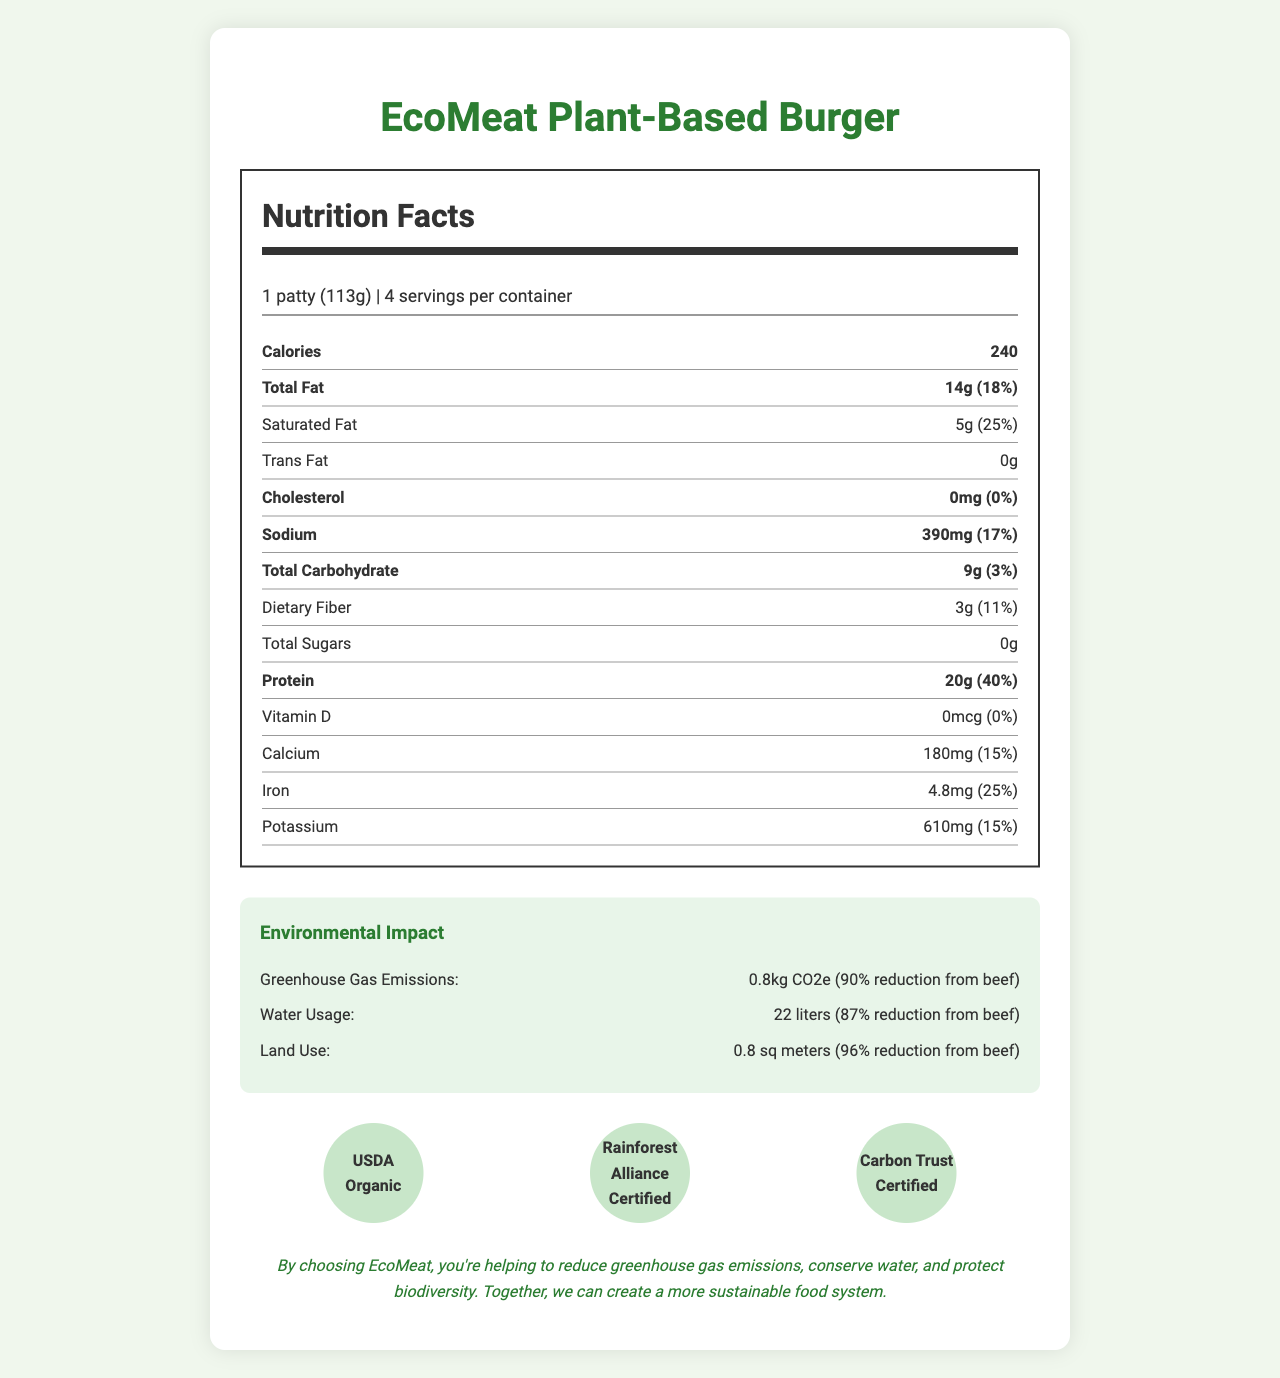what is the serving size for the EcoMeat Plant-Based Burger? The serving size is listed as "1 patty (113g)" under the nutrition facts section.
Answer: 1 patty (113g) how many grams of protein are in one serving? The nutrition facts section indicates that one serving contains 20 grams of protein.
Answer: 20g what daily value percentage of iron does one serving provide? The nutrition label shows that one serving provides 25% of the daily value of iron.
Answer: 25% how much sodium is in one serving of the product? The amount of sodium in one serving is listed as 390mg in the nutrition facts.
Answer: 390mg what is the total fat content in one serving? The nutrition facts section specifies that one serving contains 14g of total fat.
Answer: 14g how many servings are there per container? The document states there are 4 servings per container.
Answer: 4 What is the greenhouse gas emission reduction compared to beef? A. 50% B. 75% C. 90% D. 95% The environmental impact section mentions a 90% reduction in greenhouse gas emissions from beef.
Answer: C. 90% Which of the following certifications does the EcoMeat Plant-Based Burger have? i. USDA Organic ii. Fair Trade iii. Rainforest Alliance Certified iv. Carbon Trust Certified The certification section lists USDA Organic, Rainforest Alliance Certified, and Carbon Trust Certified.
Answer: i, iii, iv Is the EcoMeat Plant-Based Burger free of trans fat? The nutrition facts section states the product has 0g of trans fat.
Answer: Yes Summarize the environmental benefits of the EcoMeat Plant-Based Burger relative to beef. The environmental impact section provides specific metrics comparing the EcoMeat Plant-Based Burger to beef, highlighting major reductions in greenhouse gas emissions, water usage, and land use.
Answer: The EcoMeat Plant-Based Burger significantly reduces greenhouse gas emissions, water usage, and land use compared to beef, with reductions of 90%, 87%, and 96% respectively. What is the EcoMeat Plant-Based Burger's carbon neutrality goal? The sustainability statement details the carbon neutrality goal set for 2025.
Answer: EcoMeat aims to be carbon-neutral by 2025 through sustainable sourcing and production practices. How much calcium does one serving provide? The nutrition label indicates that one serving provides 180mg of calcium.
Answer: 180mg Can you determine the exact production process of the EcoMeat Plant-Based Burger from the document? The document provides comprehensive nutrition and environmental impact data but does not detail the specific production process.
Answer: Not enough information 